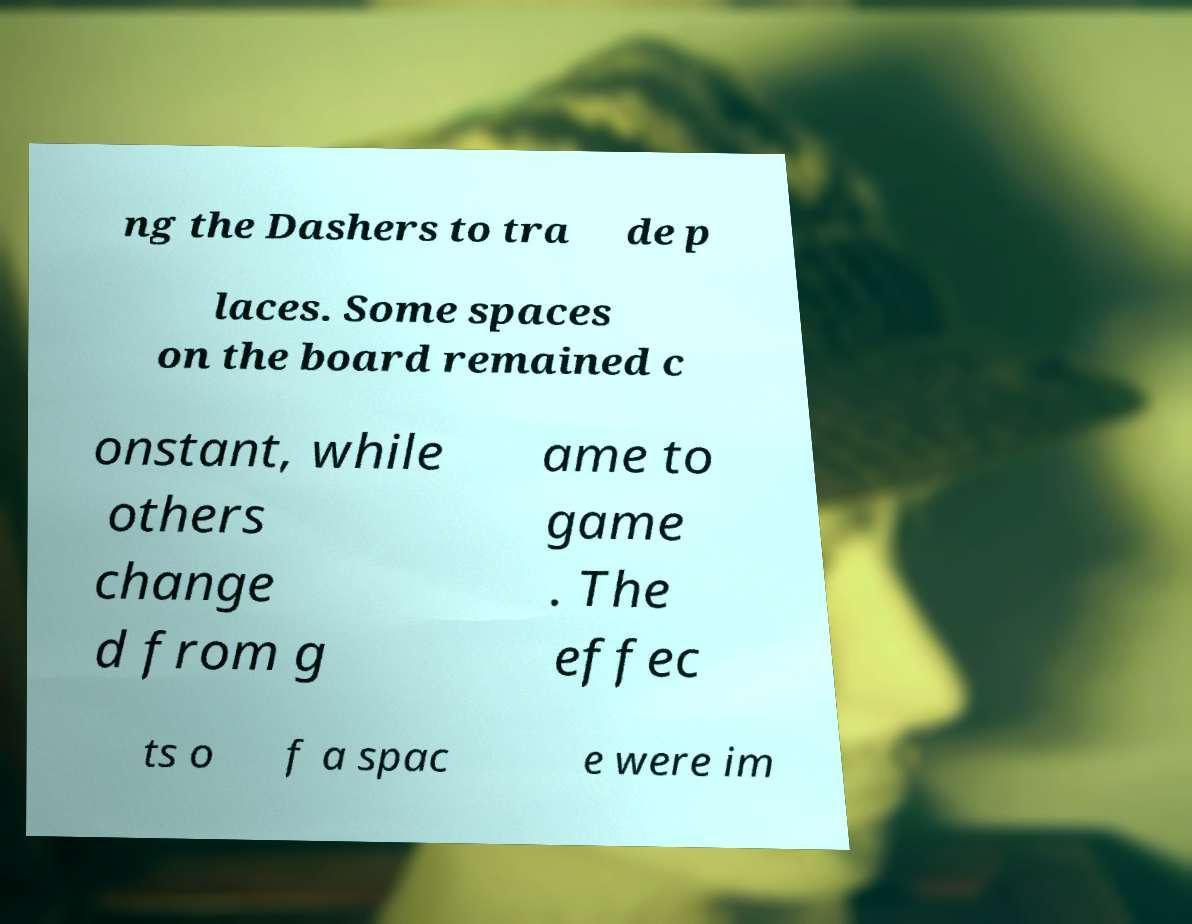Could you extract and type out the text from this image? ng the Dashers to tra de p laces. Some spaces on the board remained c onstant, while others change d from g ame to game . The effec ts o f a spac e were im 